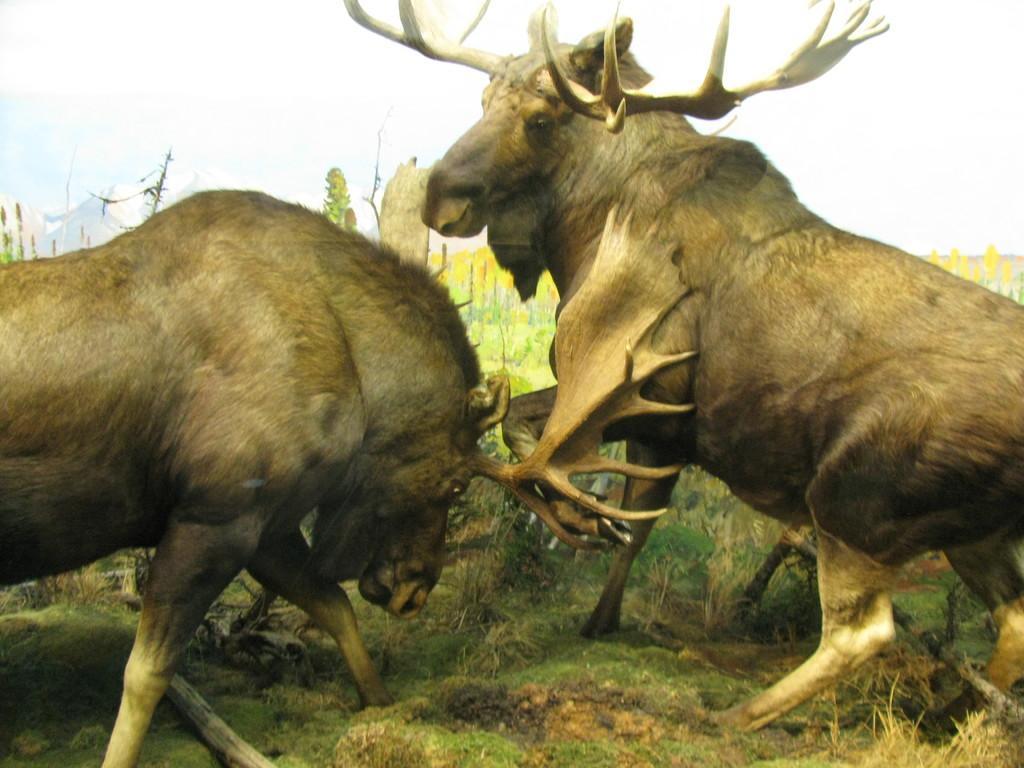Could you give a brief overview of what you see in this image? In this image we can see animals fighting with each other. 